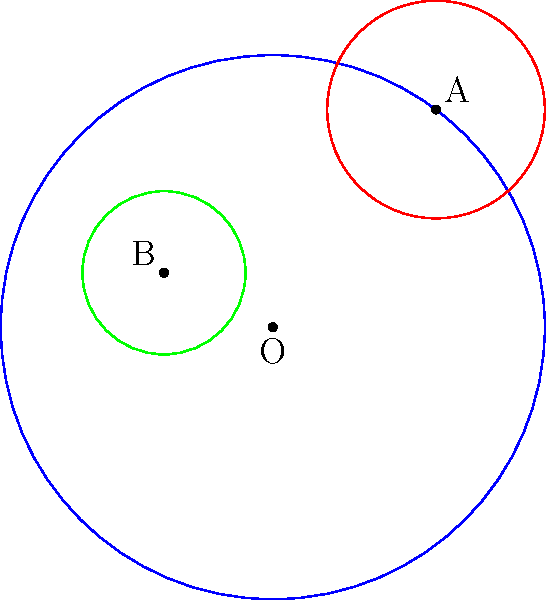In a cultural exchange event between Vietnam and Germany, three circular stages are set up. The main stage is represented by a circle centered at the origin O(0,0) with a radius of 5 units. Two smaller stages for Vietnamese and German performances are represented by circles centered at A(3,4) and B(-2,1) respectively. If the equation of the circle centered at A is $$(x-3)^2 + (y-4)^2 = 4$$, and the radius of the circle centered at B is 1.5 units, find the equation of the circle centered at B. Let's approach this step-by-step:

1) The general equation of a circle is $(x-h)^2 + (y-k)^2 = r^2$, where (h,k) is the center and r is the radius.

2) We're given that the center of circle B is at (-2,1) and its radius is 1.5 units.

3) Therefore, for the circle centered at B:
   - h = -2
   - k = 1
   - r = 1.5

4) Substituting these values into the general equation:
   $(x-(-2))^2 + (y-1)^2 = 1.5^2$

5) Simplifying:
   $(x+2)^2 + (y-1)^2 = 2.25$

This is the equation of the circle centered at B.
Answer: $(x+2)^2 + (y-1)^2 = 2.25$ 